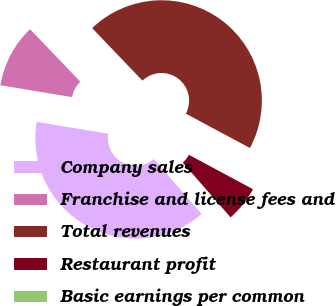Convert chart. <chart><loc_0><loc_0><loc_500><loc_500><pie_chart><fcel>Company sales<fcel>Franchise and license fees and<fcel>Total revenues<fcel>Restaurant profit<fcel>Basic earnings per common<nl><fcel>39.03%<fcel>10.24%<fcel>44.98%<fcel>5.74%<fcel>0.01%<nl></chart> 